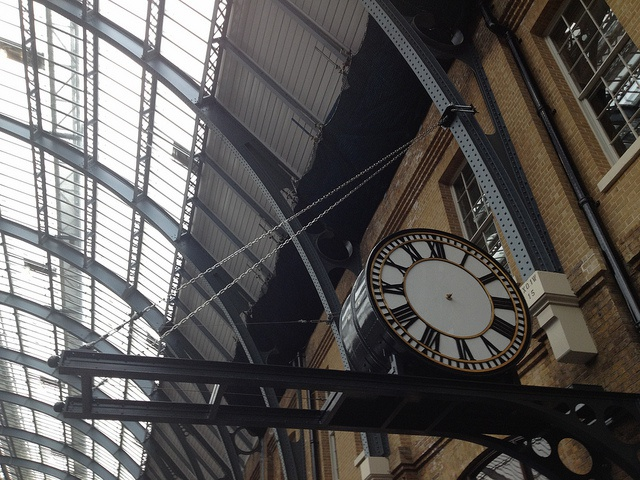Describe the objects in this image and their specific colors. I can see a clock in white, gray, black, and maroon tones in this image. 